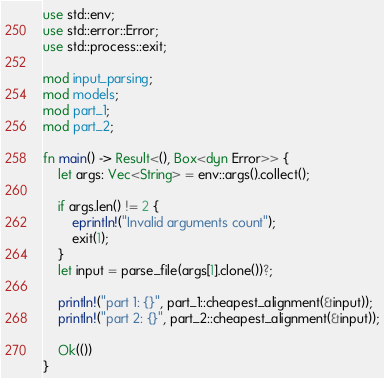<code> <loc_0><loc_0><loc_500><loc_500><_Rust_>use std::env;
use std::error::Error;
use std::process::exit;

mod input_parsing;
mod models;
mod part_1;
mod part_2;

fn main() -> Result<(), Box<dyn Error>> {
    let args: Vec<String> = env::args().collect();

    if args.len() != 2 {
        eprintln!("Invalid arguments count");
        exit(1);
    }
    let input = parse_file(args[1].clone())?;

    println!("part 1: {}", part_1::cheapest_alignment(&input));
    println!("part 2: {}", part_2::cheapest_alignment(&input));

    Ok(())
}
</code> 